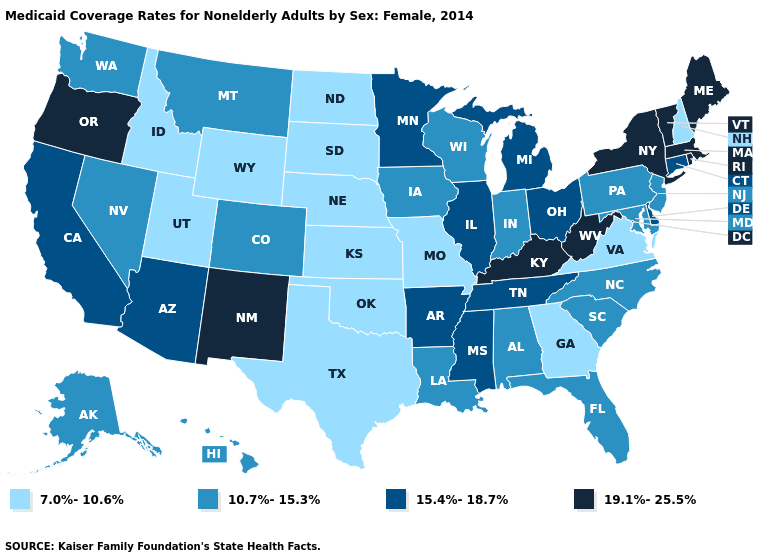Name the states that have a value in the range 10.7%-15.3%?
Keep it brief. Alabama, Alaska, Colorado, Florida, Hawaii, Indiana, Iowa, Louisiana, Maryland, Montana, Nevada, New Jersey, North Carolina, Pennsylvania, South Carolina, Washington, Wisconsin. Does New York have the highest value in the USA?
Quick response, please. Yes. Does Utah have the lowest value in the West?
Keep it brief. Yes. What is the value of Louisiana?
Be succinct. 10.7%-15.3%. Does North Carolina have the lowest value in the South?
Write a very short answer. No. Does New Hampshire have the lowest value in the Northeast?
Be succinct. Yes. Name the states that have a value in the range 19.1%-25.5%?
Be succinct. Kentucky, Maine, Massachusetts, New Mexico, New York, Oregon, Rhode Island, Vermont, West Virginia. Does Illinois have the same value as Connecticut?
Short answer required. Yes. What is the highest value in the Northeast ?
Write a very short answer. 19.1%-25.5%. Name the states that have a value in the range 7.0%-10.6%?
Quick response, please. Georgia, Idaho, Kansas, Missouri, Nebraska, New Hampshire, North Dakota, Oklahoma, South Dakota, Texas, Utah, Virginia, Wyoming. How many symbols are there in the legend?
Be succinct. 4. What is the value of Nebraska?
Write a very short answer. 7.0%-10.6%. What is the value of Oregon?
Short answer required. 19.1%-25.5%. What is the lowest value in the USA?
Be succinct. 7.0%-10.6%. Is the legend a continuous bar?
Quick response, please. No. 